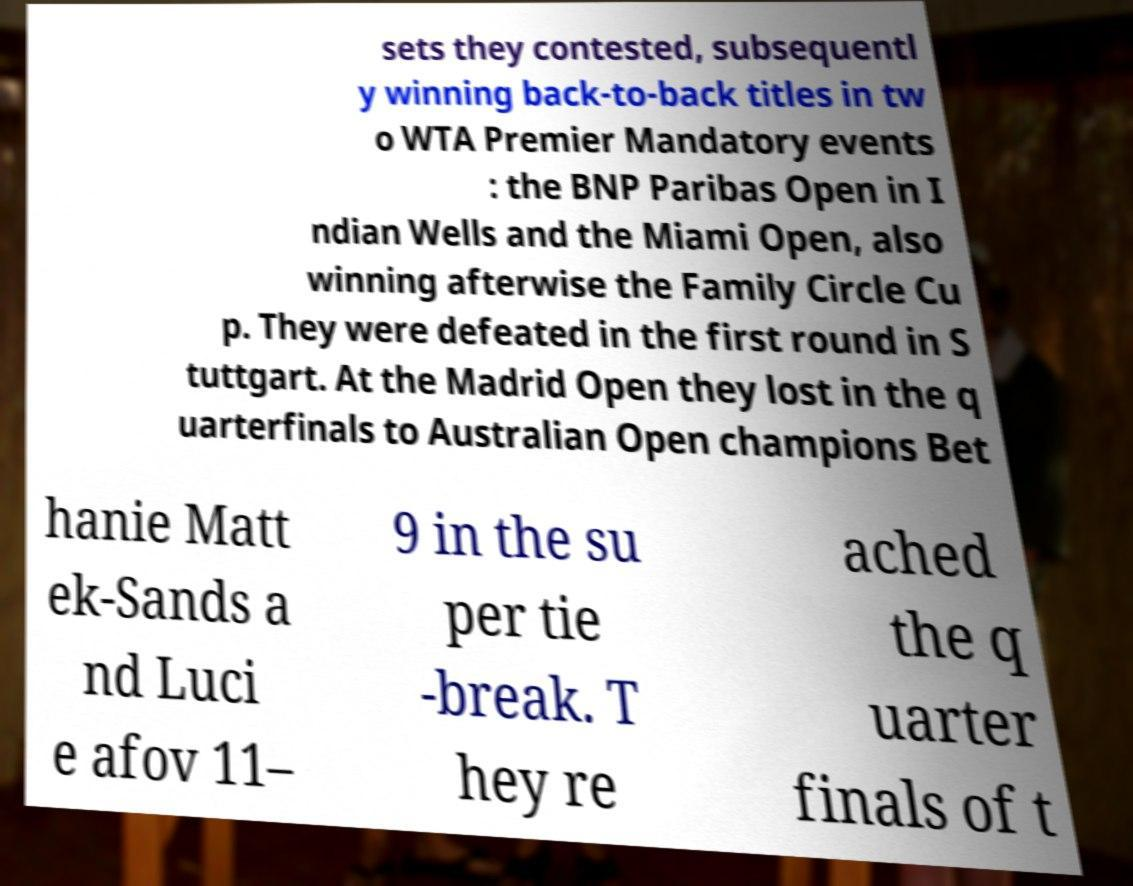What messages or text are displayed in this image? I need them in a readable, typed format. sets they contested, subsequentl y winning back-to-back titles in tw o WTA Premier Mandatory events : the BNP Paribas Open in I ndian Wells and the Miami Open, also winning afterwise the Family Circle Cu p. They were defeated in the first round in S tuttgart. At the Madrid Open they lost in the q uarterfinals to Australian Open champions Bet hanie Matt ek-Sands a nd Luci e afov 11– 9 in the su per tie -break. T hey re ached the q uarter finals of t 